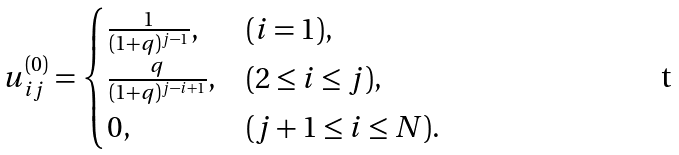<formula> <loc_0><loc_0><loc_500><loc_500>u ^ { ( 0 ) } _ { i j } = \begin{cases} \frac { 1 } { ( 1 + q ) ^ { j - 1 } } , & ( i = 1 ) , \\ \frac { q } { ( 1 + q ) ^ { j - i + 1 } } , & ( 2 \leq i \leq j ) , \\ 0 , & ( j + 1 \leq i \leq N ) . \end{cases}</formula> 